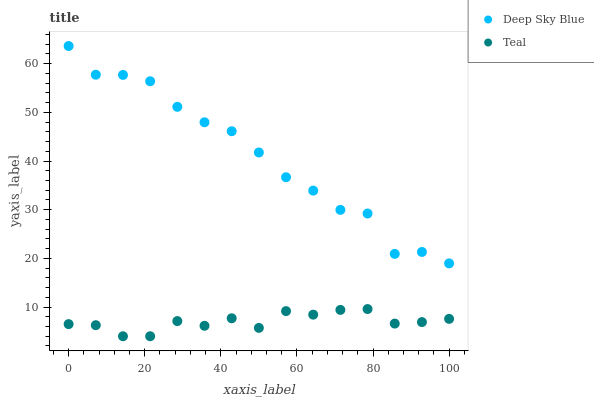Does Teal have the minimum area under the curve?
Answer yes or no. Yes. Does Deep Sky Blue have the maximum area under the curve?
Answer yes or no. Yes. Does Deep Sky Blue have the minimum area under the curve?
Answer yes or no. No. Is Teal the smoothest?
Answer yes or no. Yes. Is Deep Sky Blue the roughest?
Answer yes or no. Yes. Is Deep Sky Blue the smoothest?
Answer yes or no. No. Does Teal have the lowest value?
Answer yes or no. Yes. Does Deep Sky Blue have the lowest value?
Answer yes or no. No. Does Deep Sky Blue have the highest value?
Answer yes or no. Yes. Is Teal less than Deep Sky Blue?
Answer yes or no. Yes. Is Deep Sky Blue greater than Teal?
Answer yes or no. Yes. Does Teal intersect Deep Sky Blue?
Answer yes or no. No. 